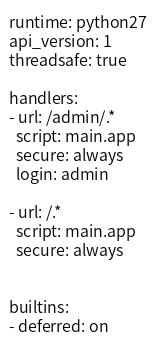Convert code to text. <code><loc_0><loc_0><loc_500><loc_500><_YAML_>runtime: python27
api_version: 1
threadsafe: true

handlers:
- url: /admin/.*
  script: main.app
  secure: always
  login: admin

- url: /.*
  script: main.app
  secure: always


builtins:
- deferred: on</code> 